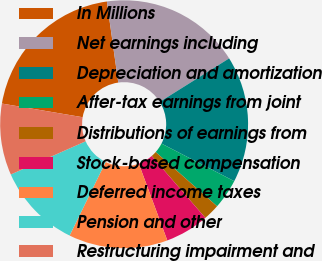<chart> <loc_0><loc_0><loc_500><loc_500><pie_chart><fcel>In Millions<fcel>Net earnings including<fcel>Depreciation and amortization<fcel>After-tax earnings from joint<fcel>Distributions of earnings from<fcel>Stock-based compensation<fcel>Deferred income taxes<fcel>Pension and other<fcel>Restructuring impairment and<nl><fcel>20.11%<fcel>18.31%<fcel>16.51%<fcel>3.91%<fcel>2.12%<fcel>5.71%<fcel>12.91%<fcel>11.11%<fcel>9.31%<nl></chart> 